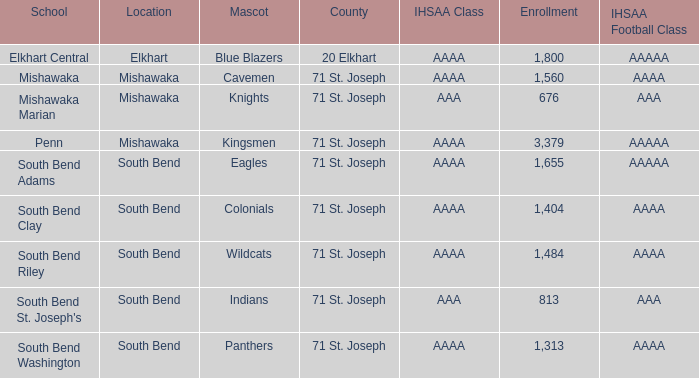What IHSAA Football Class has 20 elkhart as the county? AAAAA. 